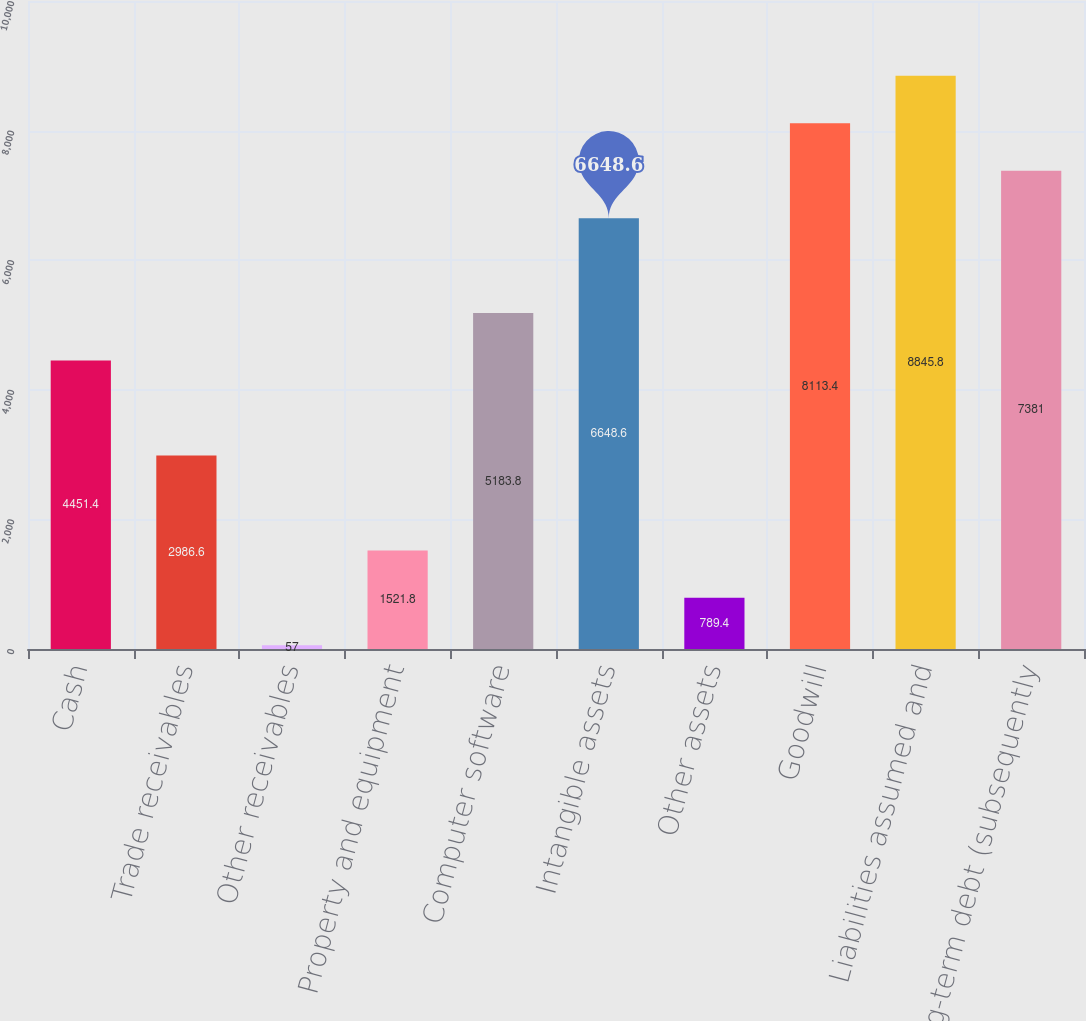<chart> <loc_0><loc_0><loc_500><loc_500><bar_chart><fcel>Cash<fcel>Trade receivables<fcel>Other receivables<fcel>Property and equipment<fcel>Computer software<fcel>Intangible assets<fcel>Other assets<fcel>Goodwill<fcel>Liabilities assumed and<fcel>Long-term debt (subsequently<nl><fcel>4451.4<fcel>2986.6<fcel>57<fcel>1521.8<fcel>5183.8<fcel>6648.6<fcel>789.4<fcel>8113.4<fcel>8845.8<fcel>7381<nl></chart> 